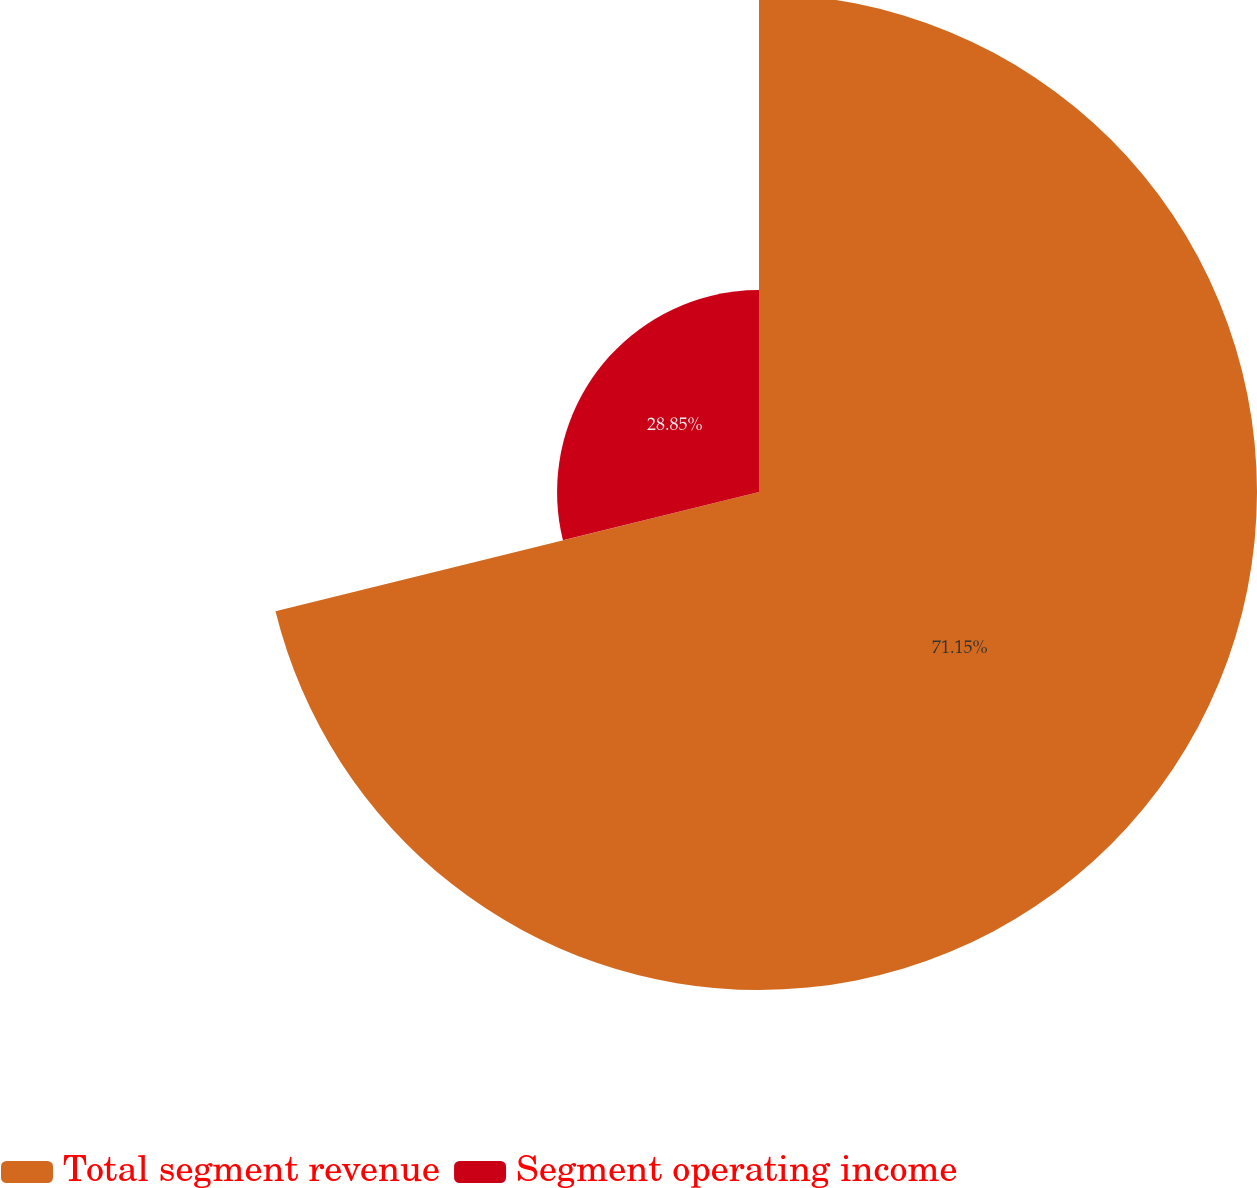Convert chart to OTSL. <chart><loc_0><loc_0><loc_500><loc_500><pie_chart><fcel>Total segment revenue<fcel>Segment operating income<nl><fcel>71.15%<fcel>28.85%<nl></chart> 